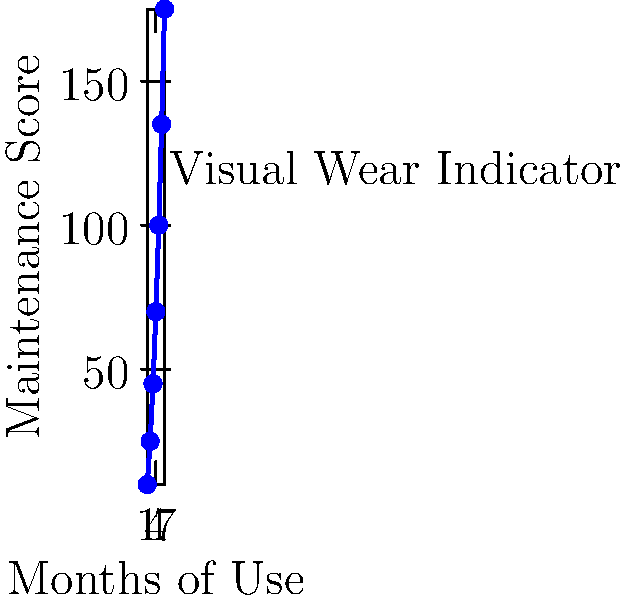Based on the graph showing the relationship between months of use and maintenance score for BMX bikes, what mathematical model best describes the trend, and how can it be used to predict when a bike will reach a critical maintenance score of 200? To answer this question, let's follow these steps:

1. Observe the graph: The relationship between months of use and maintenance score appears to be non-linear, with an increasing rate of change.

2. Identify the model: The curve resembles a quadratic function, which can be expressed as $y = ax^2 + bx + c$, where $y$ is the maintenance score and $x$ is the months of use.

3. Estimate parameters: Using the data points, we can approximate $a \approx 5$, $b \approx 0$, and $c \approx 5$. So our model is $y = 5x^2 + 5$.

4. Verify the model: Plug in some values to check if it roughly matches the graph:
   For $x = 1$: $y = 5(1)^2 + 5 = 10$
   For $x = 3$: $y = 5(3)^2 + 5 = 50$
   For $x = 6$: $y = 5(6)^2 + 5 = 185$
   These values are close to the plotted points, confirming our model.

5. Predict critical maintenance: To find when the maintenance score reaches 200, solve the equation:
   $200 = 5x^2 + 5$
   $195 = 5x^2$
   $39 = x^2$
   $x = \sqrt{39} \approx 6.24$

Therefore, the quadratic model $y = 5x^2 + 5$ can be used to predict that a bike will reach the critical maintenance score of 200 after approximately 6.24 months of use.
Answer: Quadratic model: $y = 5x^2 + 5$; Critical point at 6.24 months 